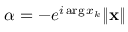<formula> <loc_0><loc_0><loc_500><loc_500>\alpha = - e ^ { i \arg x _ { k } } \| x \|</formula> 